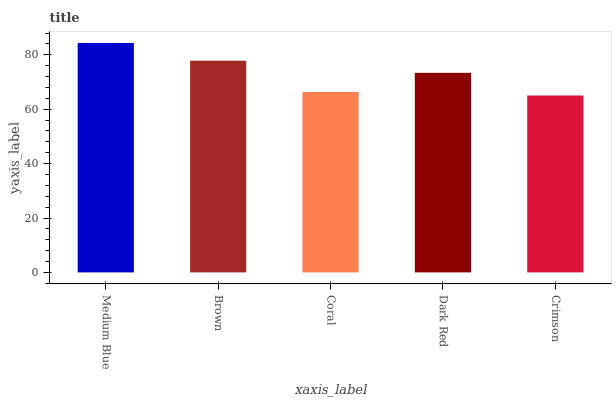Is Crimson the minimum?
Answer yes or no. Yes. Is Medium Blue the maximum?
Answer yes or no. Yes. Is Brown the minimum?
Answer yes or no. No. Is Brown the maximum?
Answer yes or no. No. Is Medium Blue greater than Brown?
Answer yes or no. Yes. Is Brown less than Medium Blue?
Answer yes or no. Yes. Is Brown greater than Medium Blue?
Answer yes or no. No. Is Medium Blue less than Brown?
Answer yes or no. No. Is Dark Red the high median?
Answer yes or no. Yes. Is Dark Red the low median?
Answer yes or no. Yes. Is Coral the high median?
Answer yes or no. No. Is Medium Blue the low median?
Answer yes or no. No. 